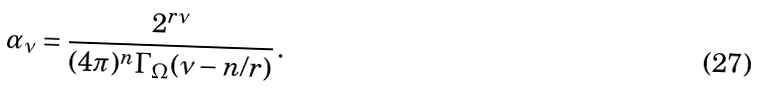Convert formula to latex. <formula><loc_0><loc_0><loc_500><loc_500>\alpha _ { \nu } = \frac { 2 ^ { r \nu } } { ( 4 \pi ) ^ { n } \Gamma _ { \Omega } ( \nu - n / r ) } \, .</formula> 